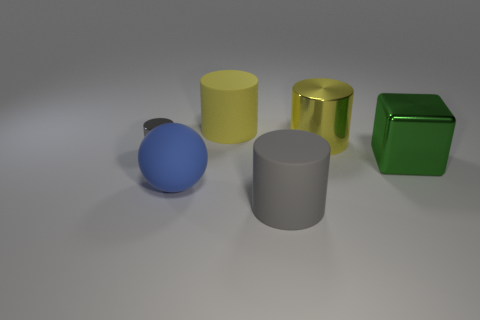What material is the big object that is the same color as the big shiny cylinder?
Offer a terse response. Rubber. There is a large cube that is the same material as the small thing; what color is it?
Ensure brevity in your answer.  Green. Are there any other things that have the same size as the blue rubber sphere?
Keep it short and to the point. Yes. How many things are either big shiny things on the right side of the yellow metal thing or big rubber cylinders that are on the right side of the large yellow rubber thing?
Keep it short and to the point. 2. There is a matte cylinder behind the yellow metallic cylinder; is its size the same as the metallic cylinder right of the tiny object?
Make the answer very short. Yes. What is the color of the other small metal thing that is the same shape as the yellow metallic object?
Offer a terse response. Gray. Is there any other thing that is the same shape as the blue rubber thing?
Give a very brief answer. No. Are there more big gray rubber objects that are right of the large blue rubber sphere than big gray rubber objects to the left of the small cylinder?
Your answer should be compact. Yes. There is a gray object on the right side of the gray object behind the big matte cylinder in front of the big sphere; what is its size?
Offer a terse response. Large. Do the large blue ball and the gray thing in front of the gray shiny object have the same material?
Make the answer very short. Yes. 